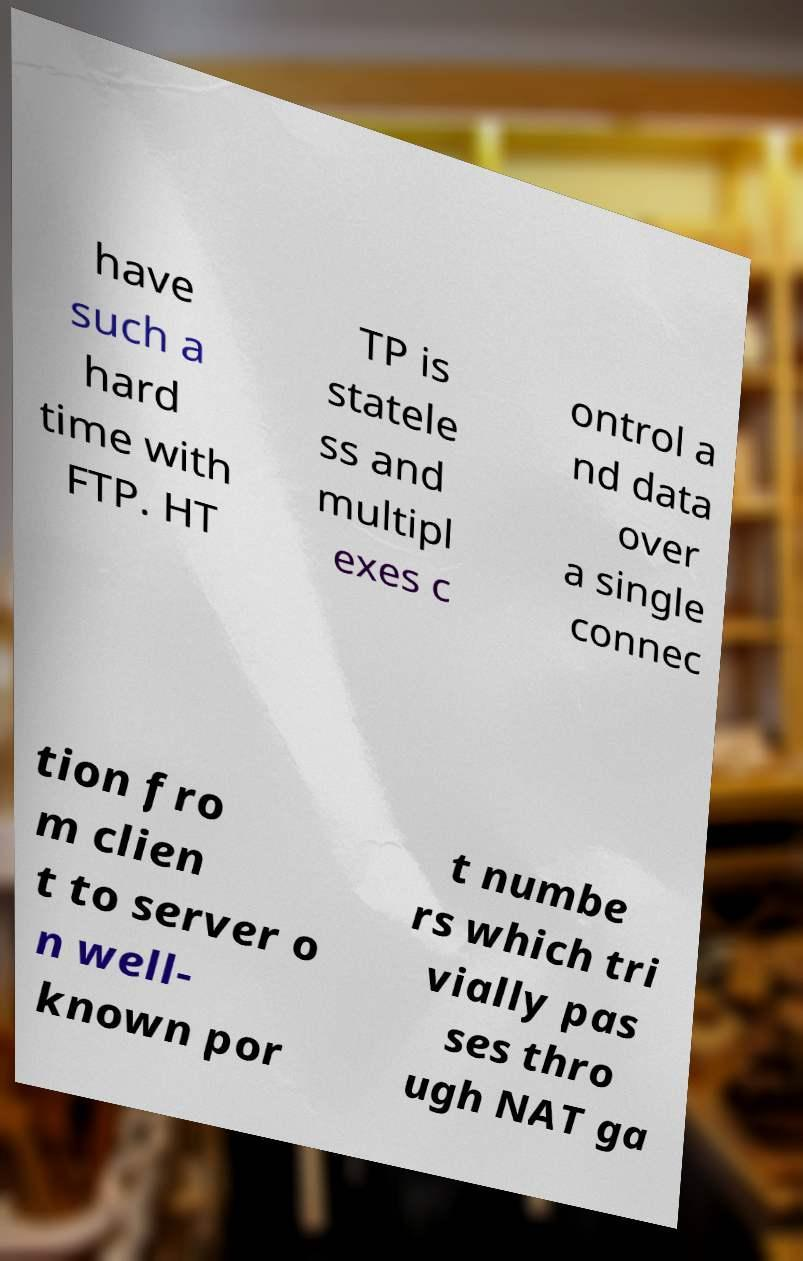Please identify and transcribe the text found in this image. have such a hard time with FTP. HT TP is statele ss and multipl exes c ontrol a nd data over a single connec tion fro m clien t to server o n well- known por t numbe rs which tri vially pas ses thro ugh NAT ga 